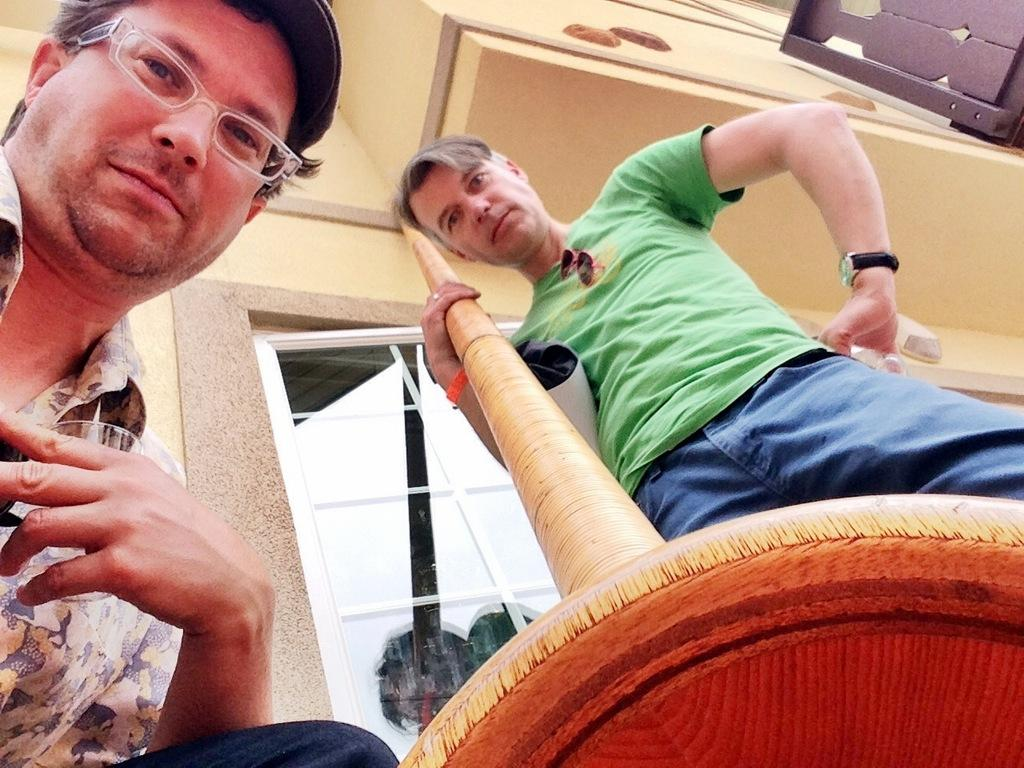How many people are in the image? There are two men in the image. What objects are being held by the people in the image? One person is holding a glass, and another person is holding a wooden pole. What can be seen in the background of the image? There is a window and a building in the background of the image. What type of hole can be seen in the image? There is no hole present in the image. How does the wind affect the people in the image? The image does not show any wind or its effects on the people. 